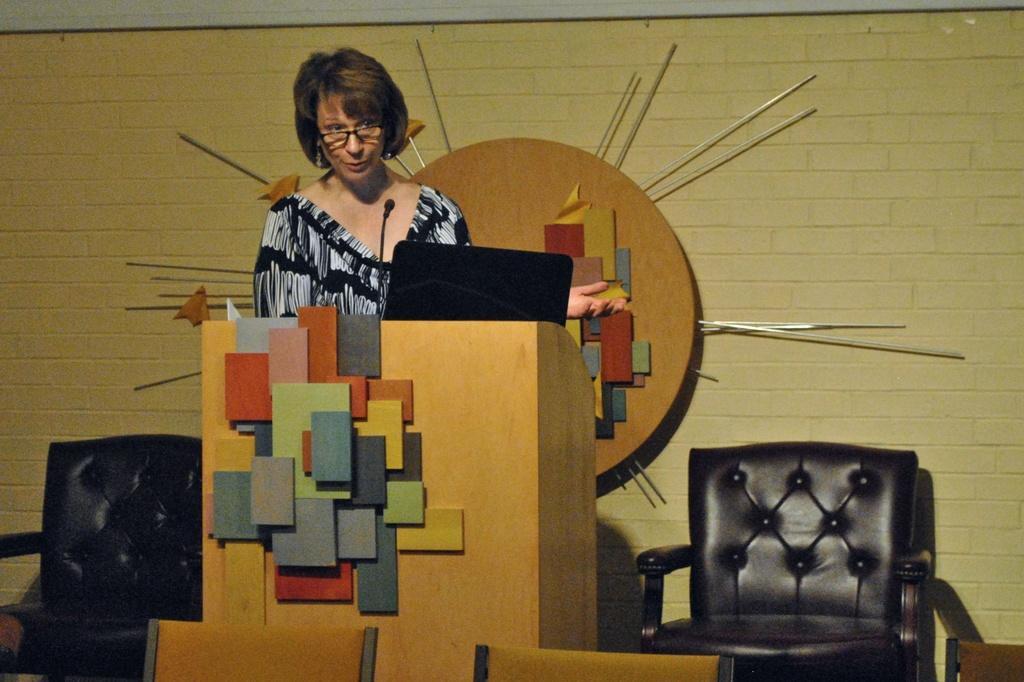Describe this image in one or two sentences. The woman in the black dress who is wearing spectacles is talking on the microphone. In front of her, we see a podium on which microphone and laptop are placed. Behind her, we see two chairs. Behind that, we see a round shaped thing is placed on the wall. At the bottom of the picture, we see the chairs. 